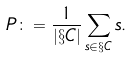Convert formula to latex. <formula><loc_0><loc_0><loc_500><loc_500>P \colon = \frac { 1 } { | \S C | } \sum _ { s \in \S C } s .</formula> 